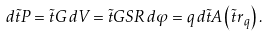Convert formula to latex. <formula><loc_0><loc_0><loc_500><loc_500>d \vec { t } { P } = \vec { t } { G } \, d V = \vec { t } { G } S R \, d \varphi = q \, d \vec { t } { A } \left ( \vec { t } { r } _ { q } \right ) .</formula> 